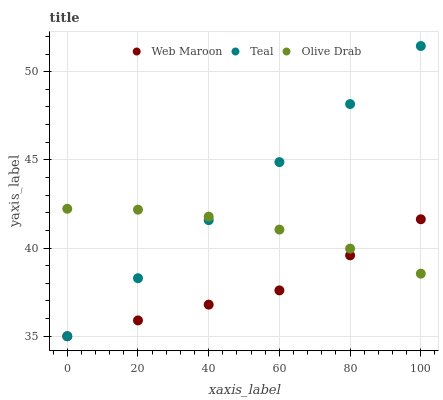Does Web Maroon have the minimum area under the curve?
Answer yes or no. Yes. Does Teal have the maximum area under the curve?
Answer yes or no. Yes. Does Olive Drab have the minimum area under the curve?
Answer yes or no. No. Does Olive Drab have the maximum area under the curve?
Answer yes or no. No. Is Teal the smoothest?
Answer yes or no. Yes. Is Olive Drab the roughest?
Answer yes or no. Yes. Is Olive Drab the smoothest?
Answer yes or no. No. Is Teal the roughest?
Answer yes or no. No. Does Web Maroon have the lowest value?
Answer yes or no. Yes. Does Olive Drab have the lowest value?
Answer yes or no. No. Does Teal have the highest value?
Answer yes or no. Yes. Does Olive Drab have the highest value?
Answer yes or no. No. Does Web Maroon intersect Teal?
Answer yes or no. Yes. Is Web Maroon less than Teal?
Answer yes or no. No. Is Web Maroon greater than Teal?
Answer yes or no. No. 